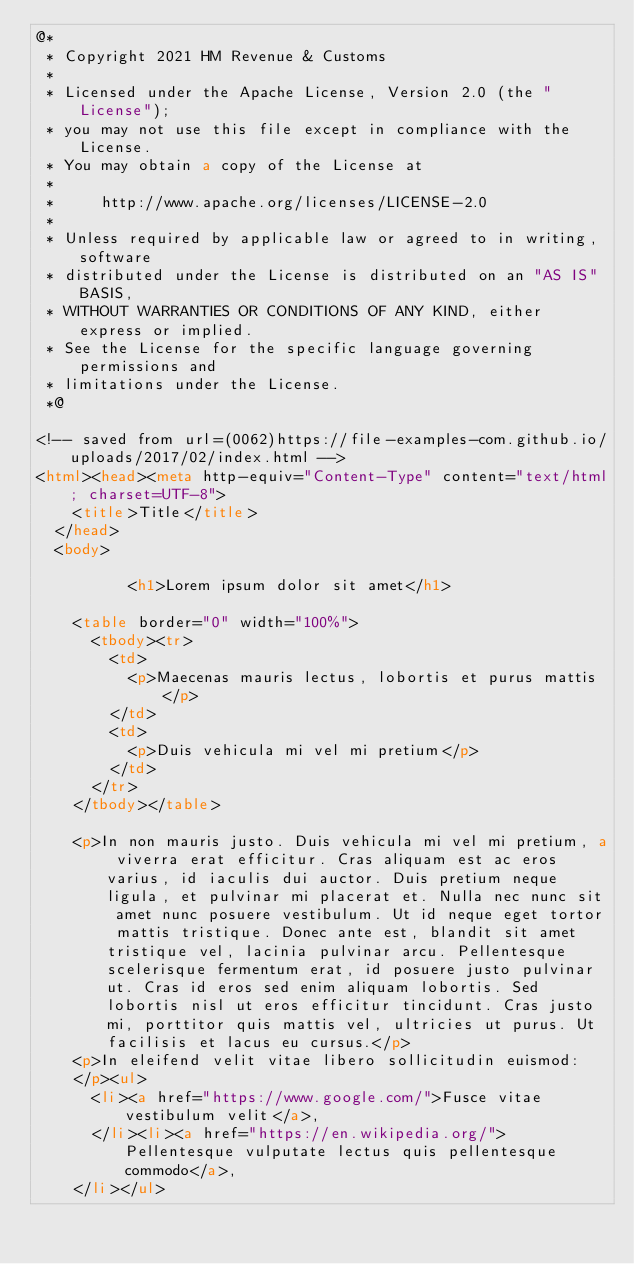<code> <loc_0><loc_0><loc_500><loc_500><_HTML_>@*
 * Copyright 2021 HM Revenue & Customs
 *
 * Licensed under the Apache License, Version 2.0 (the "License");
 * you may not use this file except in compliance with the License.
 * You may obtain a copy of the License at
 *
 *     http://www.apache.org/licenses/LICENSE-2.0
 *
 * Unless required by applicable law or agreed to in writing, software
 * distributed under the License is distributed on an "AS IS" BASIS,
 * WITHOUT WARRANTIES OR CONDITIONS OF ANY KIND, either express or implied.
 * See the License for the specific language governing permissions and
 * limitations under the License.
 *@

<!-- saved from url=(0062)https://file-examples-com.github.io/uploads/2017/02/index.html -->
<html><head><meta http-equiv="Content-Type" content="text/html; charset=UTF-8">
    <title>Title</title>
  </head>
  <body>

          <h1>Lorem ipsum dolor sit amet</h1>    

    <table border="0" width="100%">
      <tbody><tr>
        <td>
          <p>Maecenas mauris lectus, lobortis et purus mattis</p>
        </td>
        <td>
          <p>Duis vehicula mi vel mi pretium</p>
        </td>
      </tr>
    </tbody></table>

    <p>In non mauris justo. Duis vehicula mi vel mi pretium, a viverra erat efficitur. Cras aliquam est ac eros varius, id iaculis dui auctor. Duis pretium neque ligula, et pulvinar mi placerat et. Nulla nec nunc sit amet nunc posuere vestibulum. Ut id neque eget tortor mattis tristique. Donec ante est, blandit sit amet tristique vel, lacinia pulvinar arcu. Pellentesque scelerisque fermentum erat, id posuere justo pulvinar ut. Cras id eros sed enim aliquam lobortis. Sed lobortis nisl ut eros efficitur tincidunt. Cras justo mi, porttitor quis mattis vel, ultricies ut purus. Ut facilisis et lacus eu cursus.</p>
    <p>In eleifend velit vitae libero sollicitudin euismod:
    </p><ul>
      <li><a href="https://www.google.com/">Fusce vitae vestibulum velit</a>,
      </li><li><a href="https://en.wikipedia.org/">Pellentesque vulputate lectus quis pellentesque commodo</a>,
    </li></ul>

</code> 